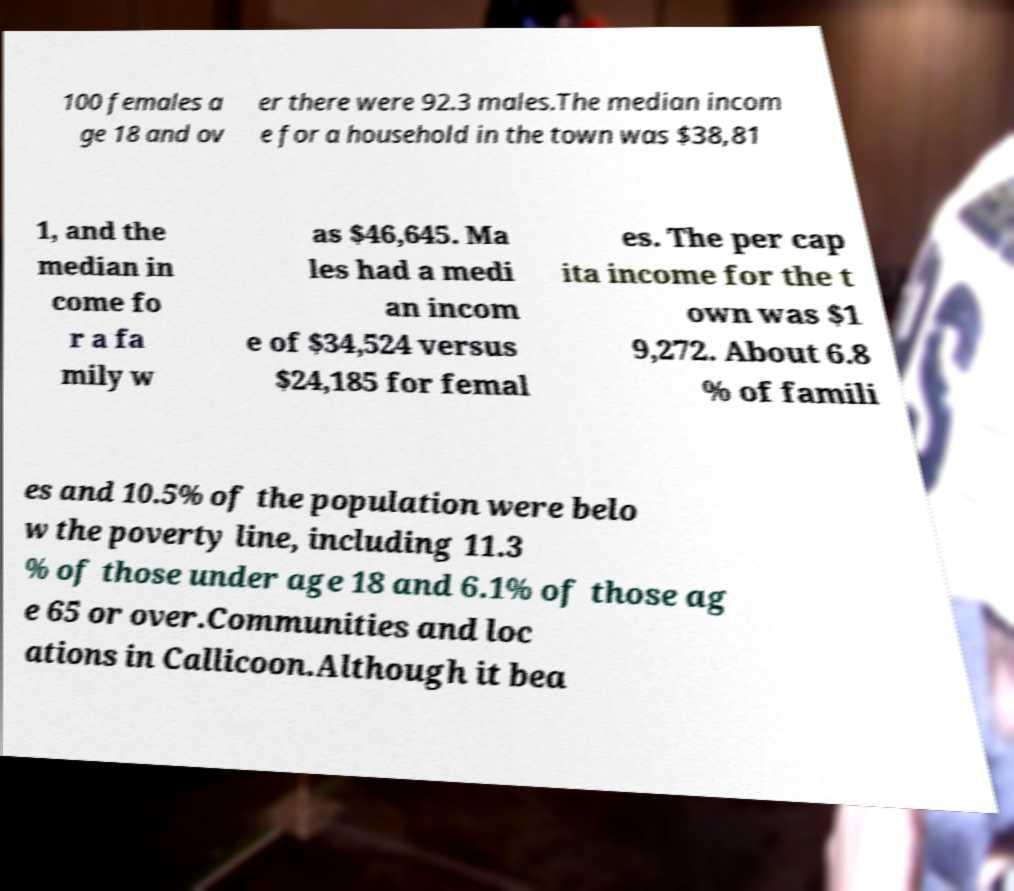Please identify and transcribe the text found in this image. 100 females a ge 18 and ov er there were 92.3 males.The median incom e for a household in the town was $38,81 1, and the median in come fo r a fa mily w as $46,645. Ma les had a medi an incom e of $34,524 versus $24,185 for femal es. The per cap ita income for the t own was $1 9,272. About 6.8 % of famili es and 10.5% of the population were belo w the poverty line, including 11.3 % of those under age 18 and 6.1% of those ag e 65 or over.Communities and loc ations in Callicoon.Although it bea 